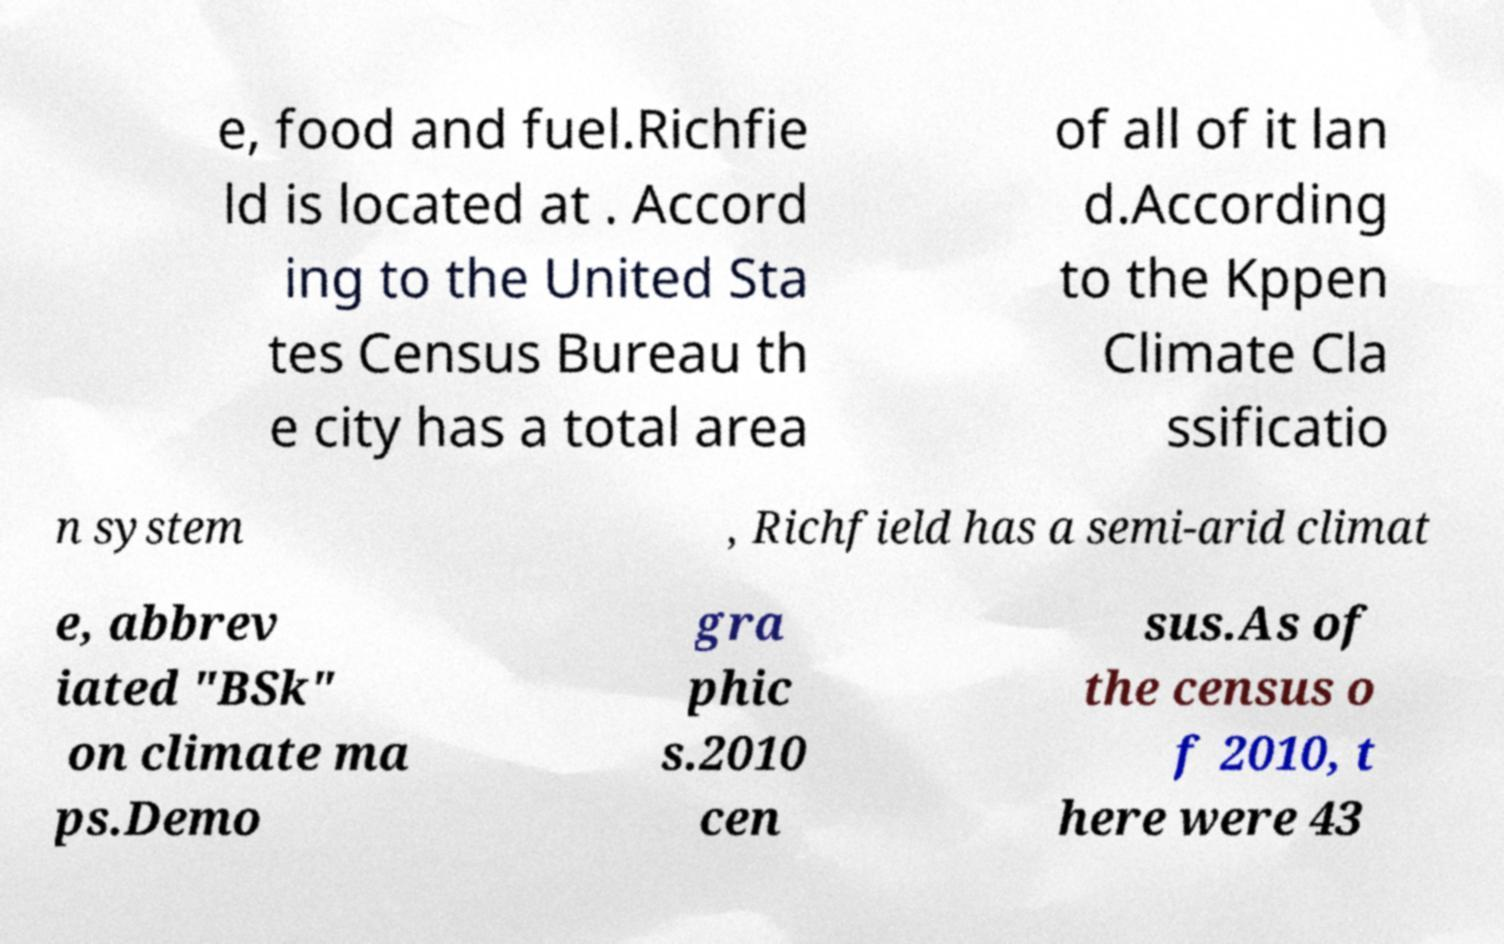Please read and relay the text visible in this image. What does it say? e, food and fuel.Richfie ld is located at . Accord ing to the United Sta tes Census Bureau th e city has a total area of all of it lan d.According to the Kppen Climate Cla ssificatio n system , Richfield has a semi-arid climat e, abbrev iated "BSk" on climate ma ps.Demo gra phic s.2010 cen sus.As of the census o f 2010, t here were 43 